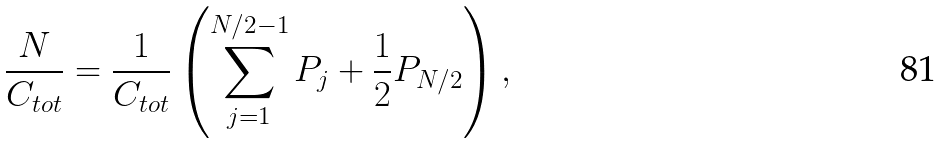Convert formula to latex. <formula><loc_0><loc_0><loc_500><loc_500>\frac { N } { C _ { t o t } } = \frac { 1 } { C _ { t o t } } \left ( \sum _ { j = 1 } ^ { N / 2 - 1 } P _ { j } + \frac { 1 } { 2 } P _ { N / 2 } \right ) ,</formula> 